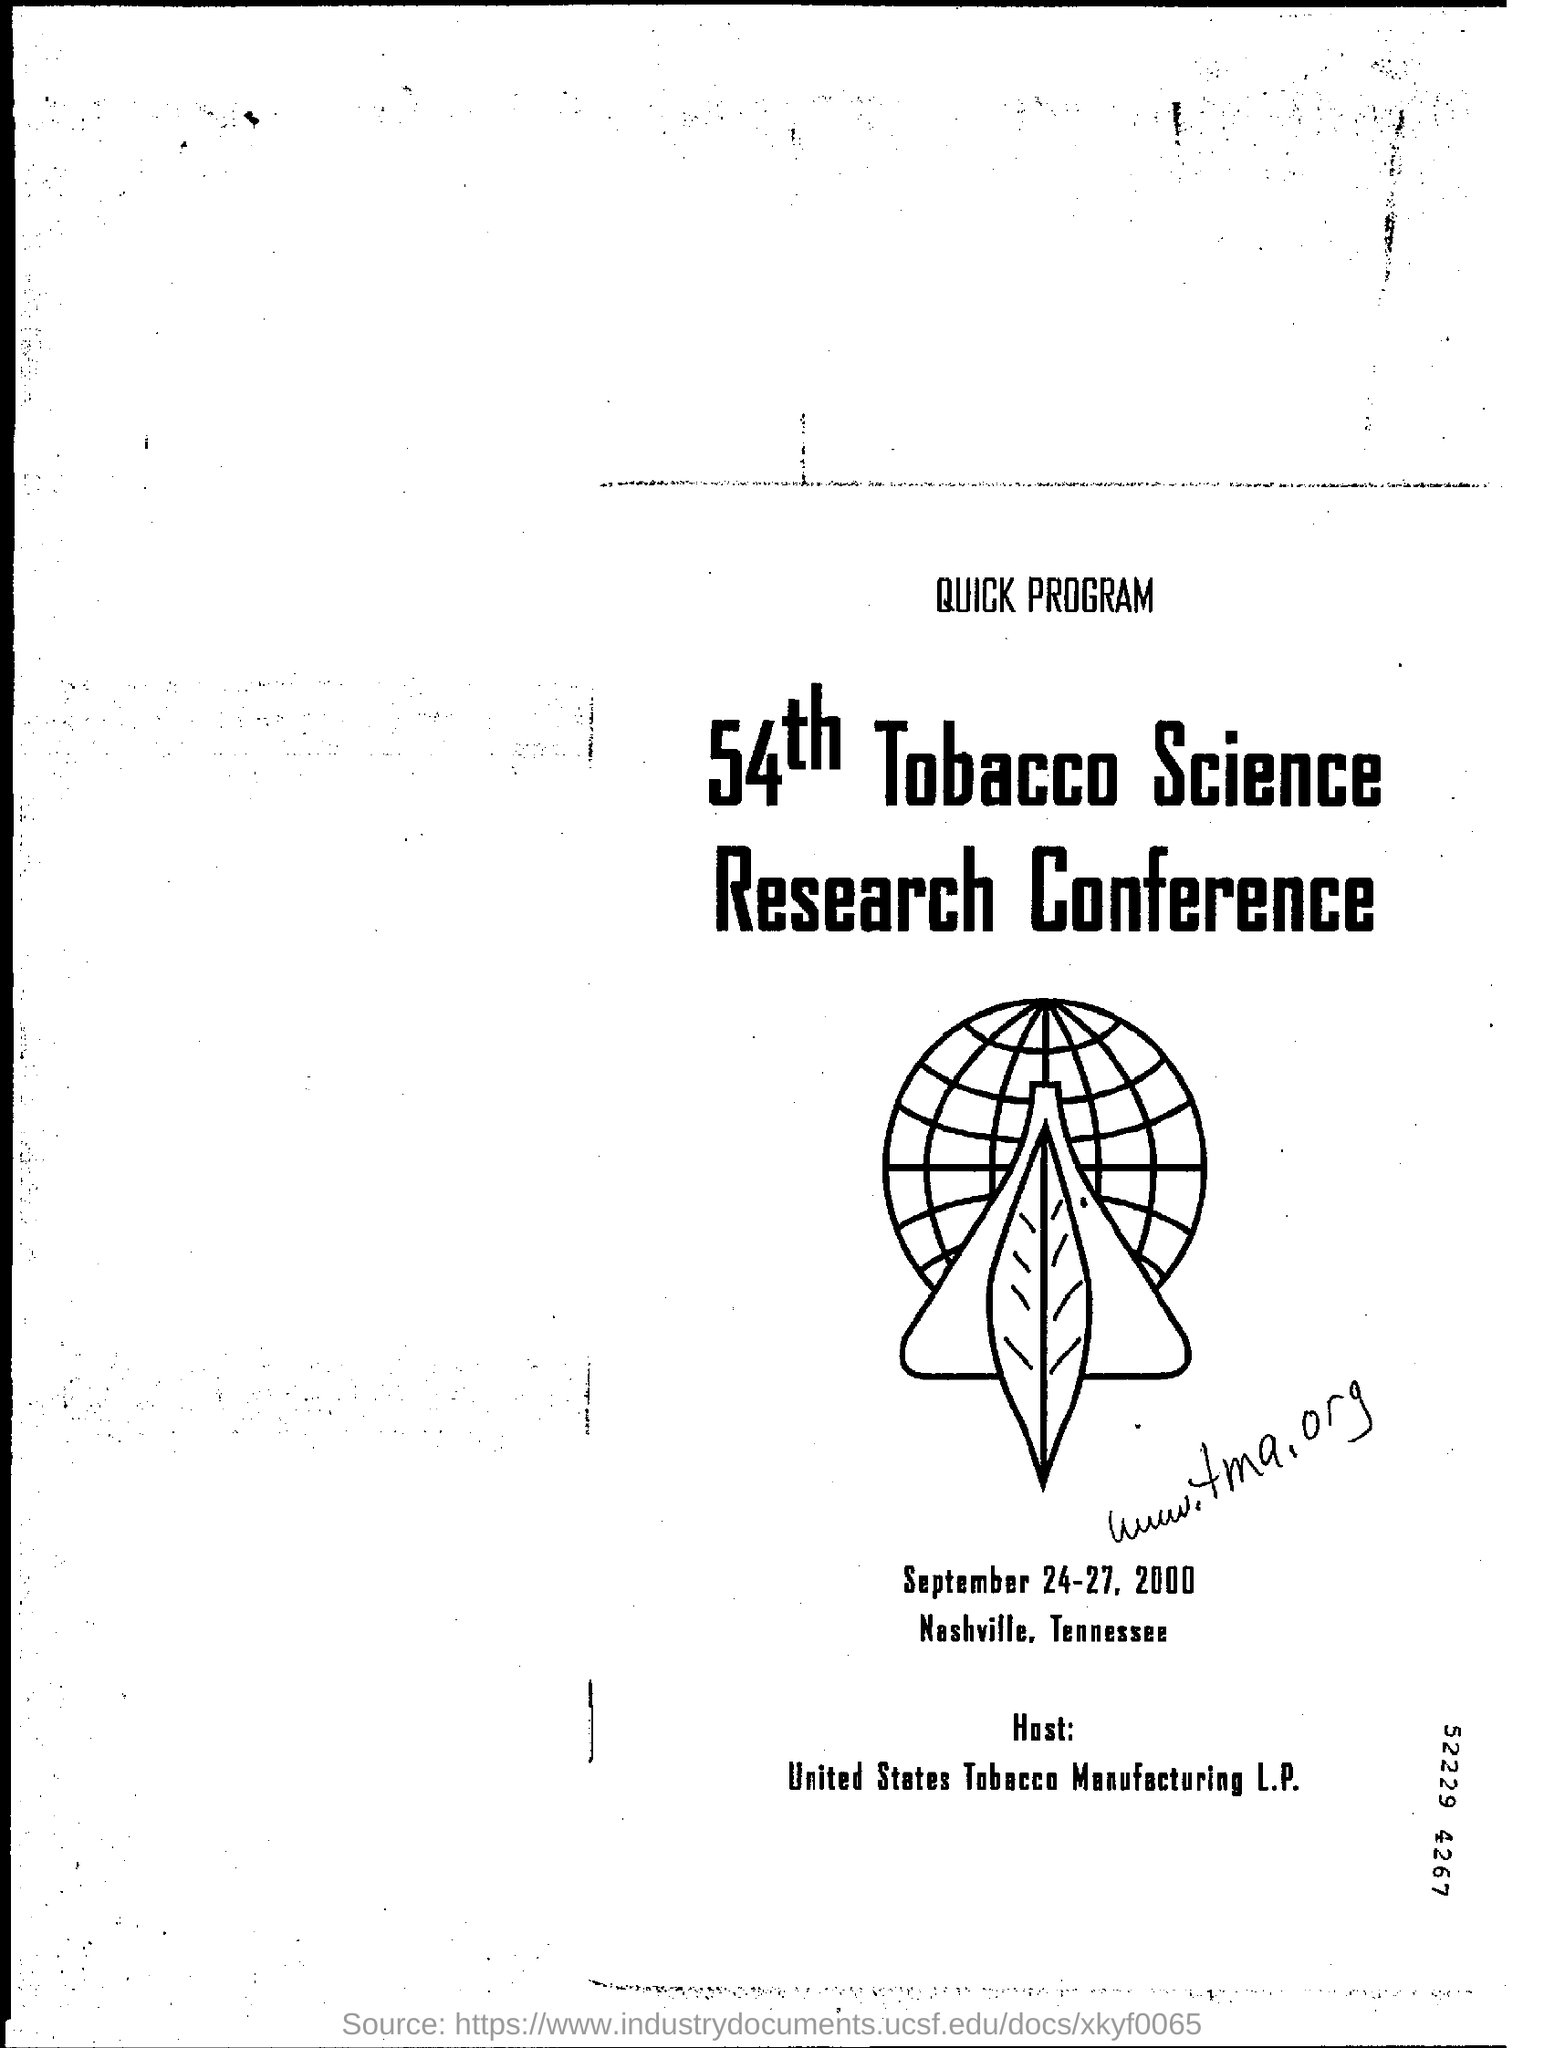Draw attention to some important aspects in this diagram. The conference is being hosted by the United States Tobacco Manufacturing Limited Partnership. The conference is held in Nashville. The 54th Tobacco Science Research Conference is named "X". 